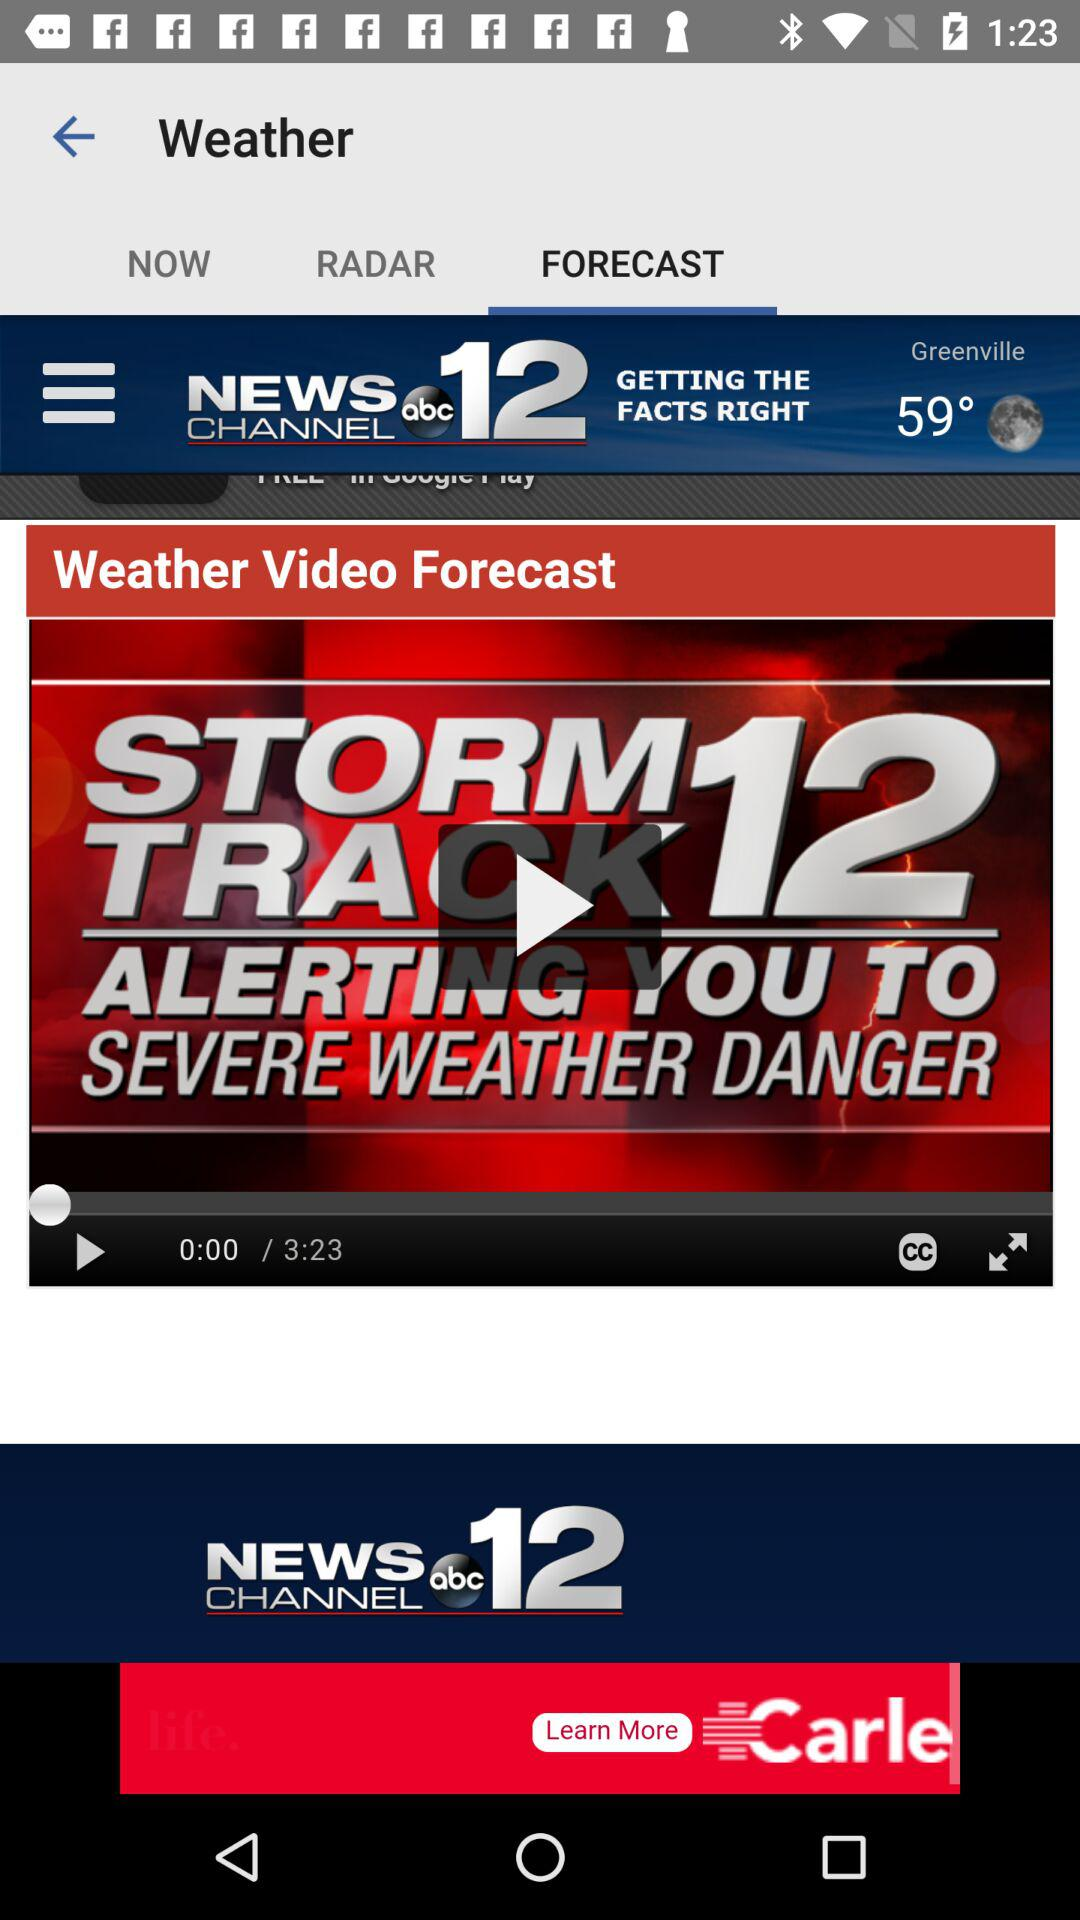What is the video's duration? The duration of the video is 3 minutes and 23 seconds. 